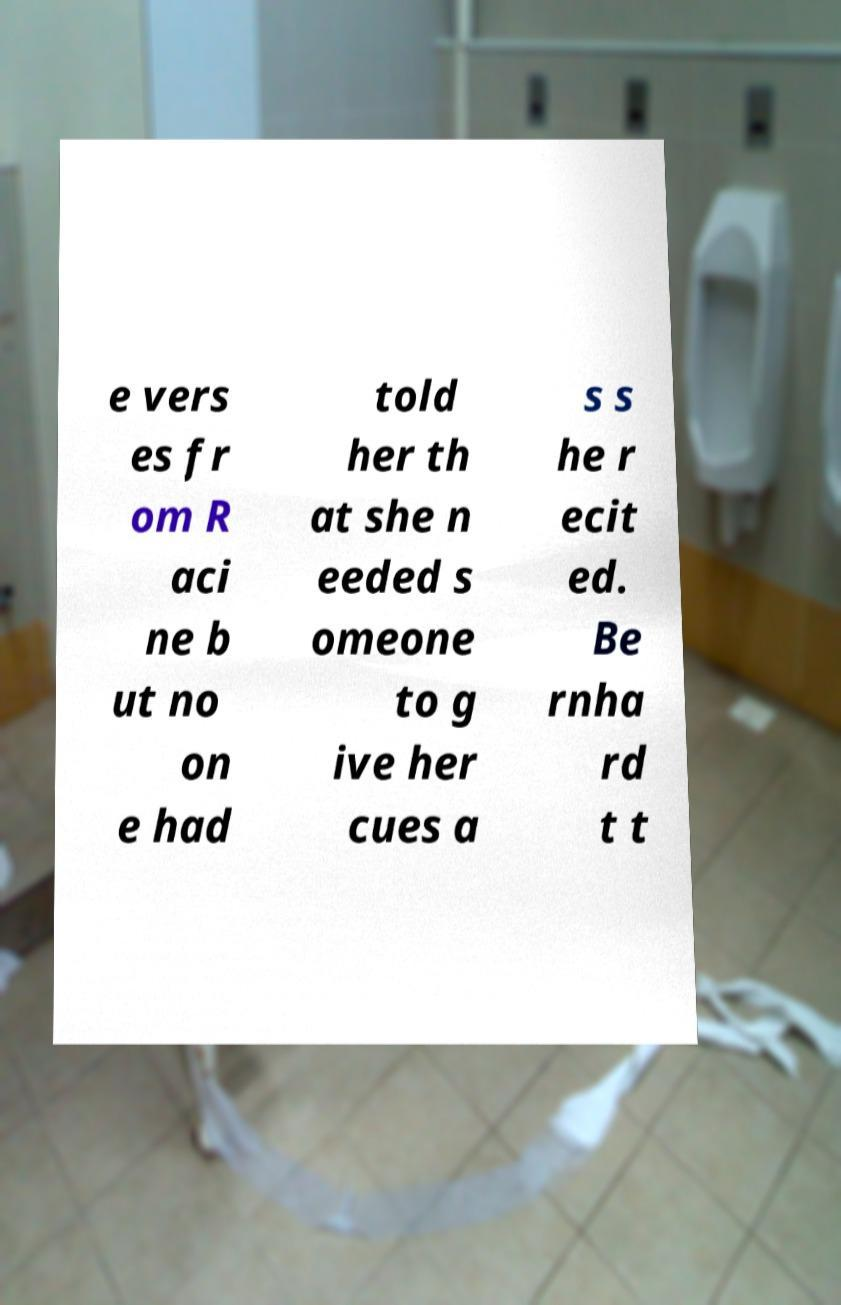For documentation purposes, I need the text within this image transcribed. Could you provide that? e vers es fr om R aci ne b ut no on e had told her th at she n eeded s omeone to g ive her cues a s s he r ecit ed. Be rnha rd t t 